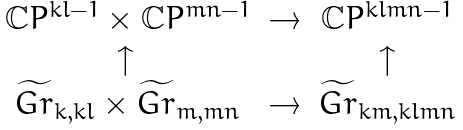<formula> <loc_0><loc_0><loc_500><loc_500>\begin{array} { c c c } \mathbb { C } P ^ { k l - 1 } \times \mathbb { C } P ^ { m n - 1 } & \rightarrow & \mathbb { C } P ^ { k l m n - 1 } \\ \uparrow \, & & \uparrow \\ \widetilde { G r } _ { k , k l } \times \widetilde { G r } _ { m , m n } & \rightarrow & \widetilde { G r } _ { k m , k l m n } \\ \end{array}</formula> 